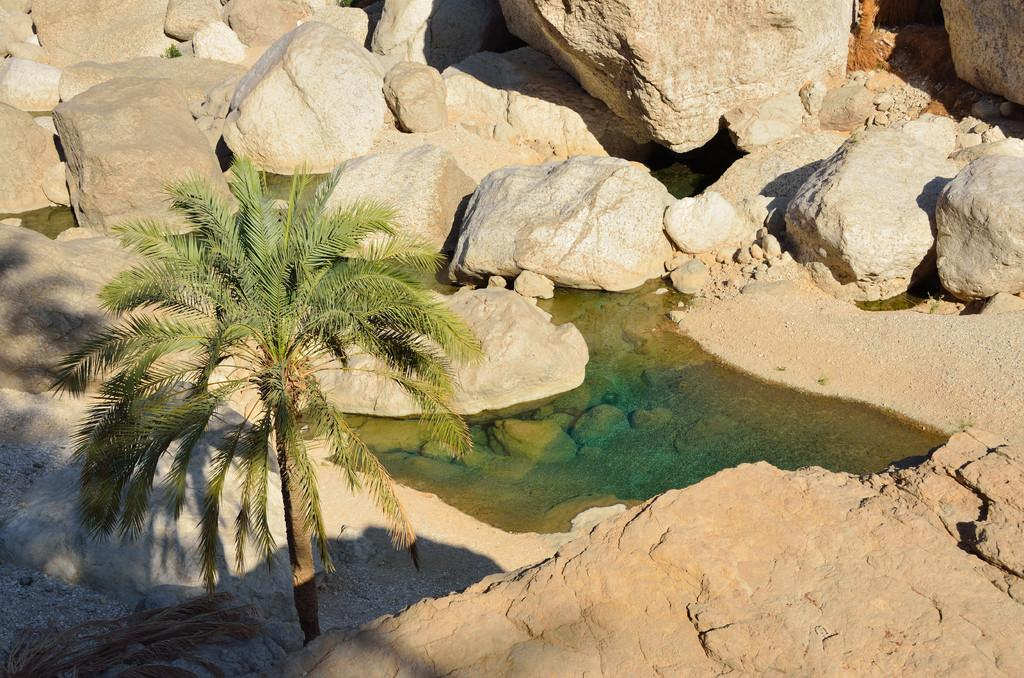What type of natural elements can be seen in the image? There are many rocks and a tree in the image. Is there any water visible in the image? Yes, there is water visible in the image. What type of polish is being applied to the owl in the image? There is no owl or polish present in the image; it features rocks, a tree, and water. 